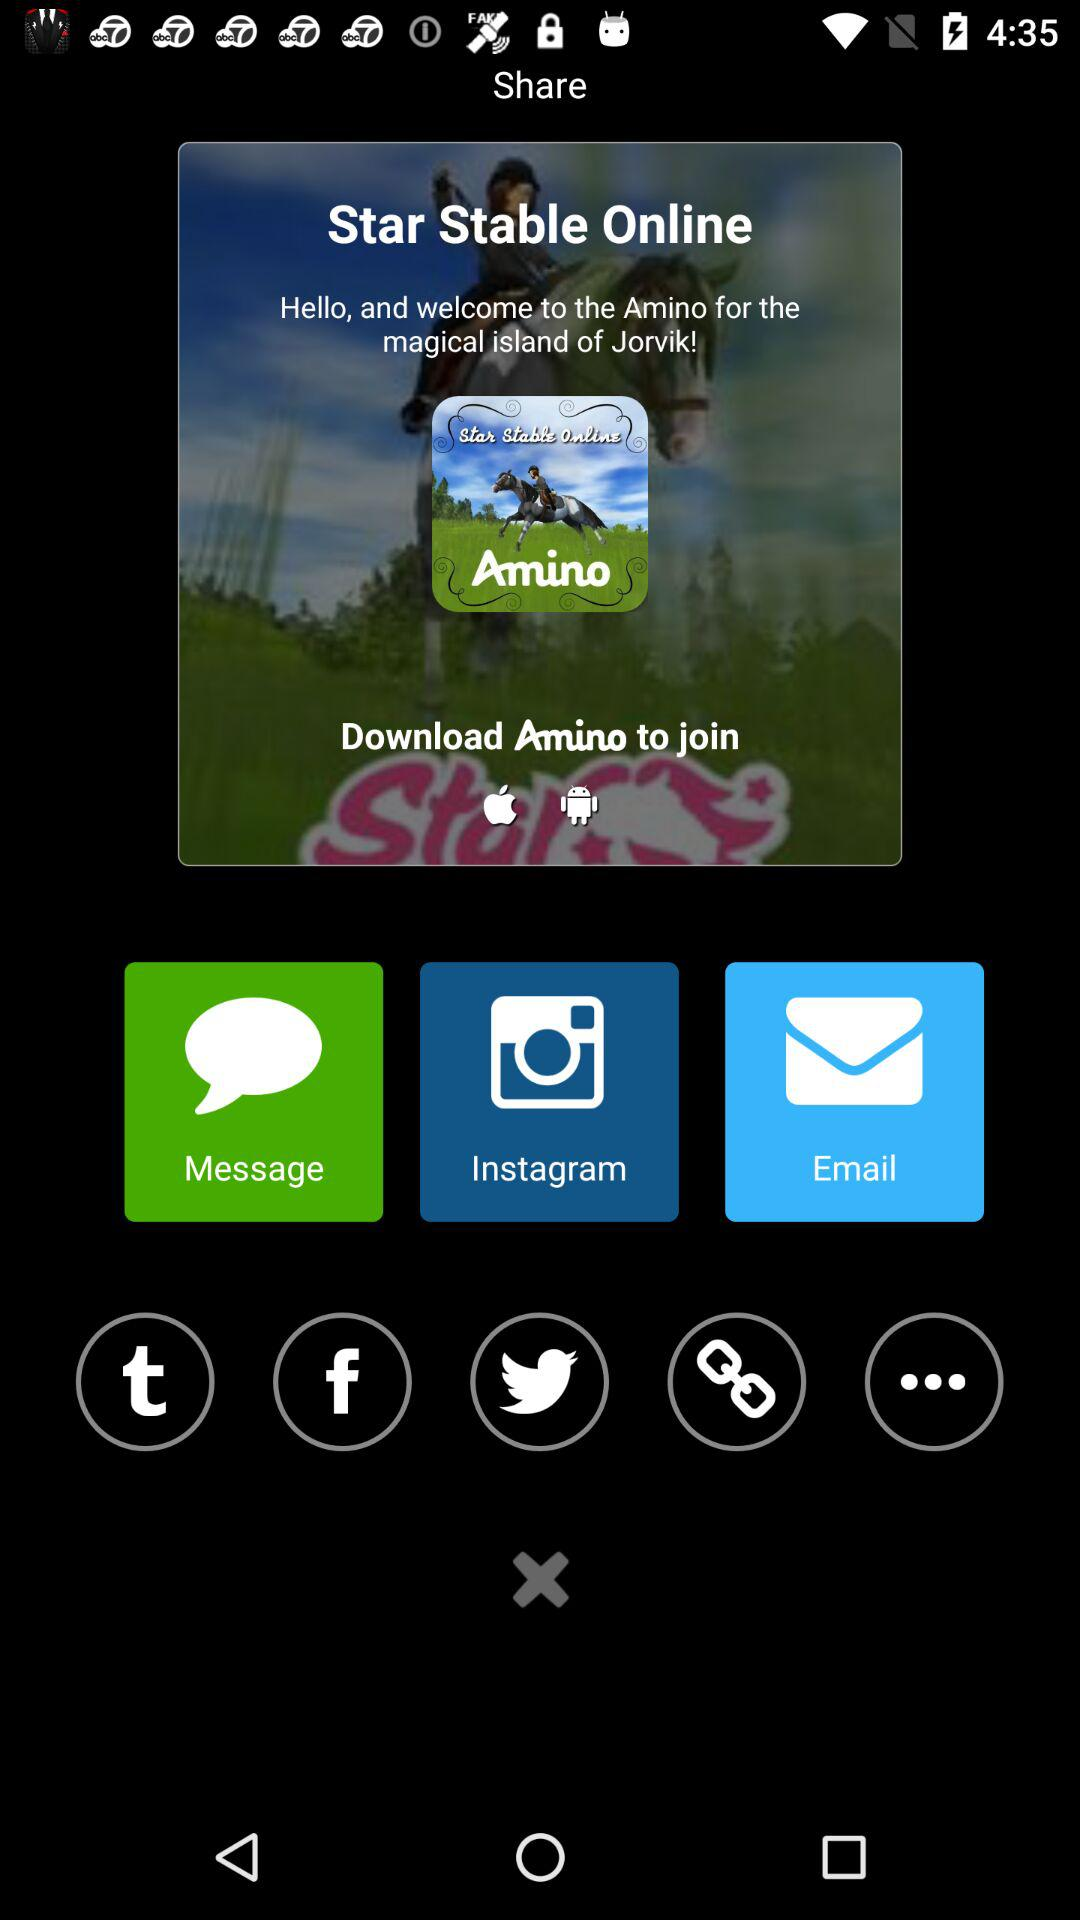Which applications can be used to share? The applications that can be used to share are "Message", "Instagram", "Tumblr", "Facebook" and "Twitter". 